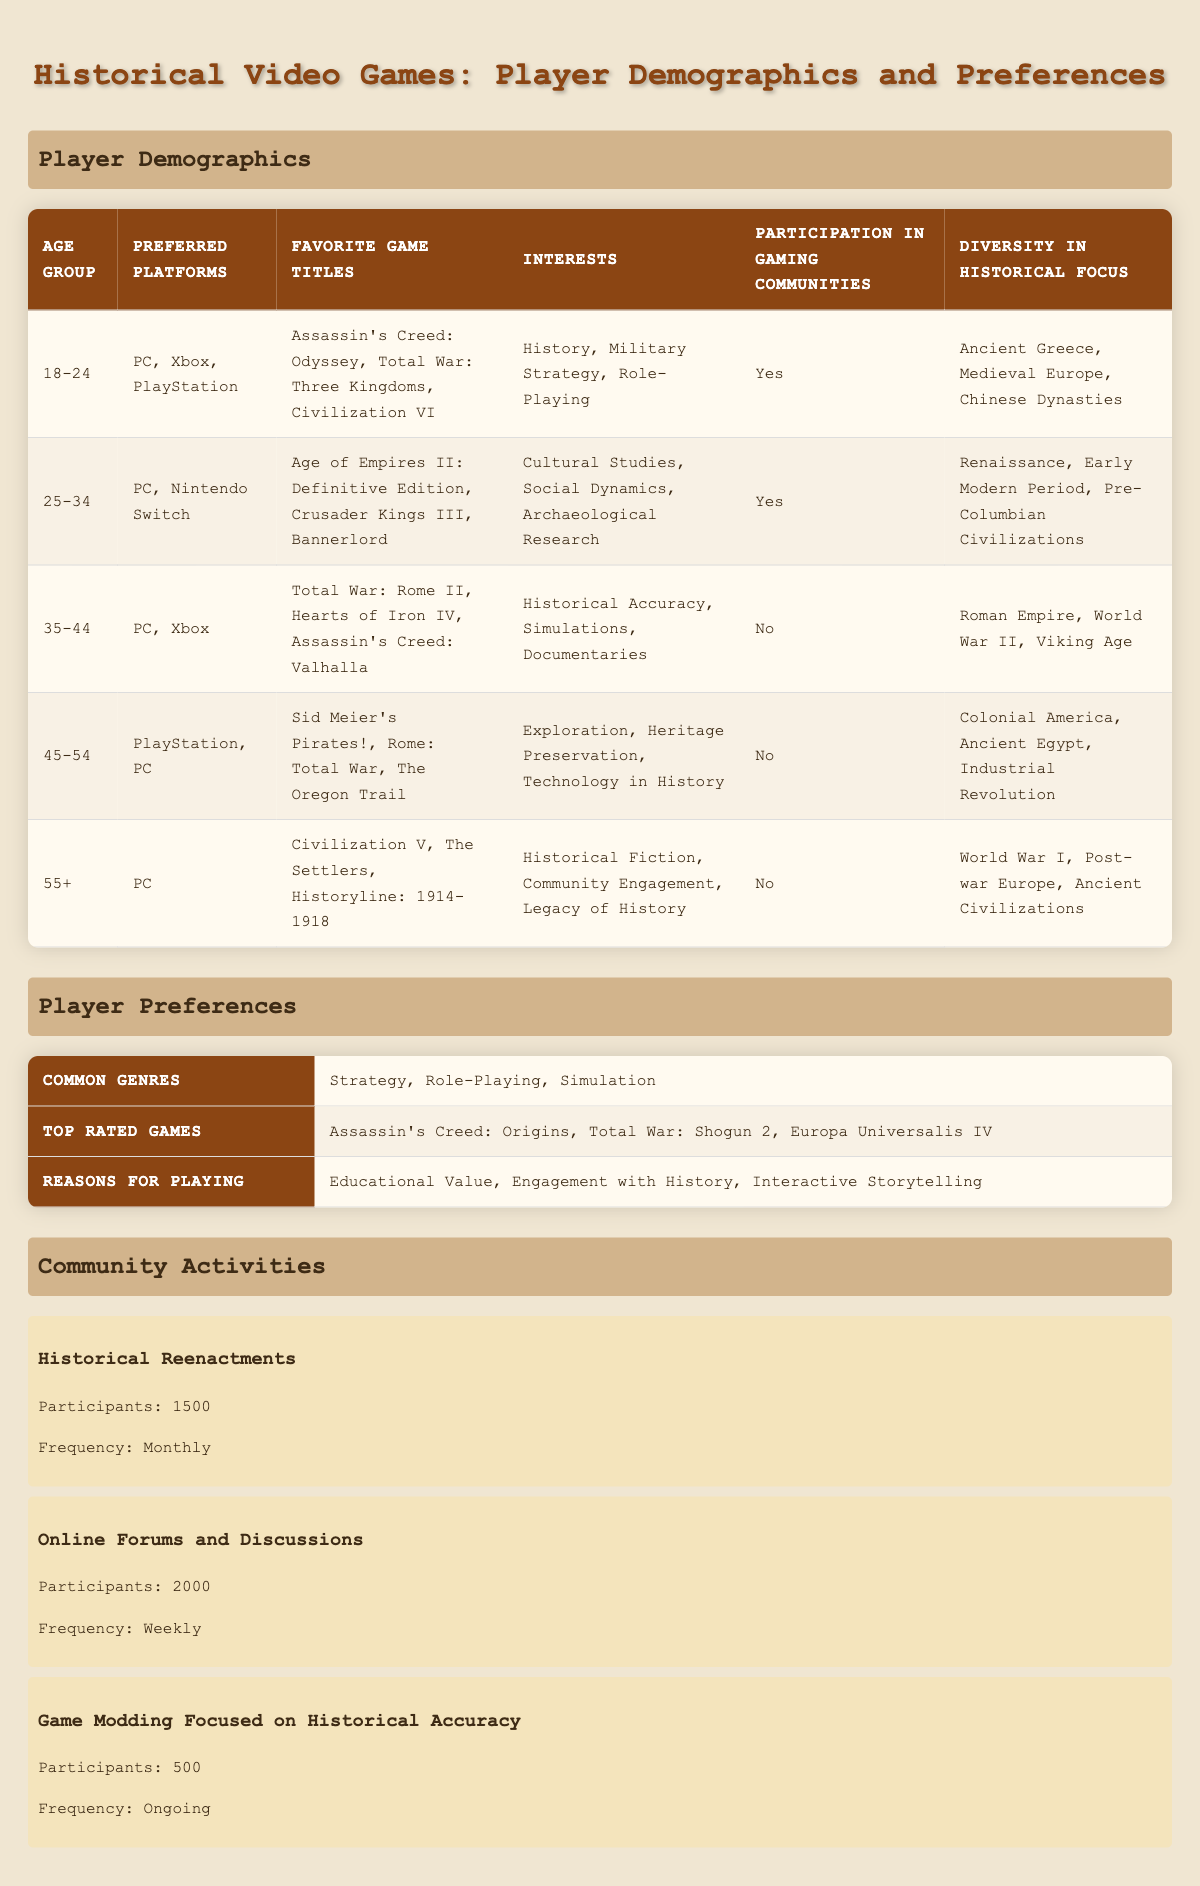What is the most preferred platform for players aged 25-34? According to the table, the preferred platforms for the 25-34 age group are PC and Nintendo Switch. Since "PC" is mentioned first, it can be determined as the most preferred platform for this age group.
Answer: PC How many historical video game titles are listed for the 45-54 age group? The table lists three favorite game titles for the 45-54 age group: Sid Meier's Pirates!, Rome: Total War, and The Oregon Trail. Thus, there are three titles in total.
Answer: 3 Is there any age group that does not participate in gaming communities? The table shows that both the 35-44, 45-54, and 55+ age groups have "No" for participation in gaming communities, which confirms that these groups do not engage in such activities.
Answer: Yes Which age group has the most diverse historical focus according to the table? The 18-24 age group lists historical focuses of Ancient Greece, Medieval Europe, and Chinese Dynasties, which include three different historical regions. The other age groups have fewer unique regions. Therefore, the 18-24 age group has the most diverse historical focus.
Answer: 18-24 What is the percentage of players aged 35-44 who participate in gaming communities? The table indicates that there are four age groups; only the 18-24 and 25-34 age groups participate in gaming communities, while the 35-44 age group does not. Therefore, the participation percentage for the 35-44 age group is calculated as 0 out of 5 age groups, resulting in 0%.
Answer: 0% What are the top three interests for players aged 18-24? According to the data provided for the 18-24 age group, the interests are History, Military Strategy, and Role-Playing. These are directly quoted from the table.
Answer: History, Military Strategy, Role-Playing How do the preferred platforms for the 25-34 age group compare to those of the 55+ age group? The 25-34 age group prefers PC and Nintendo Switch, while the 55+ age group prefers only PC. This means that the 25-34 age group has a broader platform preference, including Nintendo Switch.
Answer: 25-34 has PC and Nintendo Switch; 55+ has PC only Which player demographic has an interest in archaeological research? The table states that the 25-34 age group lists "Archaeological Research" as one of their interests, while other age groups do not mention this interest. Hence, the 25-34 age group is explicitly associated with archaeological research.
Answer: 25-34 What is the average number of participants in community activities listed in the table? The community activities show participants as 1500 for Historical Reenactments, 2000 for Online Forums and Discussions, and 500 for Game Modding Focused on Historical Accuracy. Calculating the average: (1500 + 2000 + 500) / 3 = 1500. The average number of community activity participants is thus 1500.
Answer: 1500 